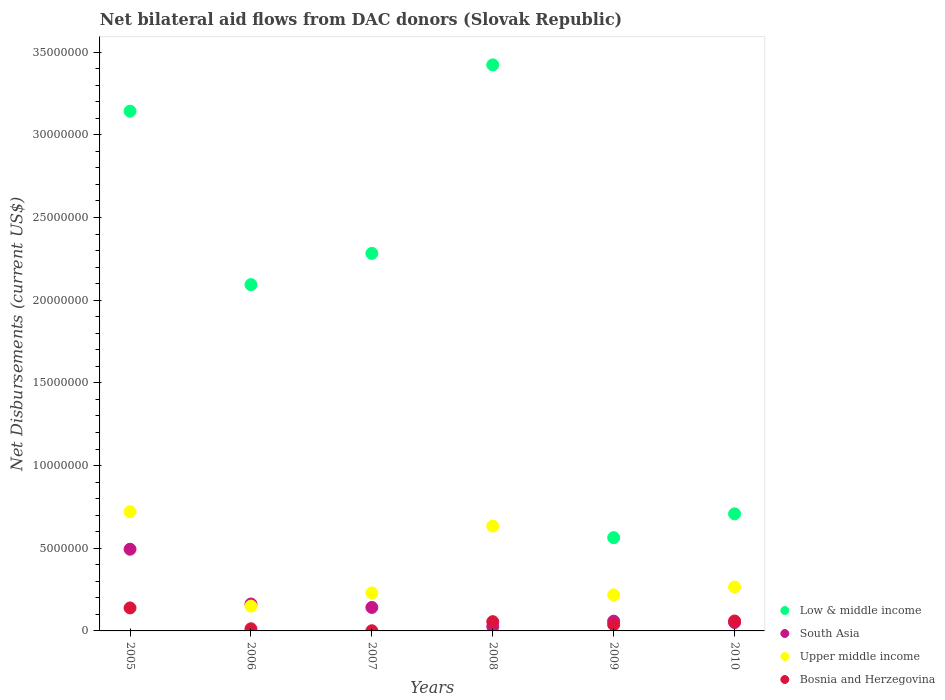Is the number of dotlines equal to the number of legend labels?
Give a very brief answer. Yes. What is the net bilateral aid flows in Upper middle income in 2005?
Ensure brevity in your answer.  7.21e+06. Across all years, what is the maximum net bilateral aid flows in South Asia?
Make the answer very short. 4.94e+06. Across all years, what is the minimum net bilateral aid flows in South Asia?
Offer a terse response. 2.60e+05. In which year was the net bilateral aid flows in Bosnia and Herzegovina maximum?
Provide a succinct answer. 2005. In which year was the net bilateral aid flows in South Asia minimum?
Your answer should be very brief. 2008. What is the total net bilateral aid flows in Low & middle income in the graph?
Make the answer very short. 1.22e+08. What is the difference between the net bilateral aid flows in Upper middle income in 2009 and that in 2010?
Your answer should be very brief. -4.70e+05. What is the difference between the net bilateral aid flows in Bosnia and Herzegovina in 2007 and the net bilateral aid flows in Low & middle income in 2009?
Make the answer very short. -5.63e+06. What is the average net bilateral aid flows in Low & middle income per year?
Ensure brevity in your answer.  2.04e+07. In the year 2007, what is the difference between the net bilateral aid flows in Low & middle income and net bilateral aid flows in Upper middle income?
Make the answer very short. 2.05e+07. What is the ratio of the net bilateral aid flows in Upper middle income in 2007 to that in 2009?
Offer a terse response. 1.06. Is the net bilateral aid flows in Bosnia and Herzegovina in 2008 less than that in 2009?
Offer a very short reply. No. Is the difference between the net bilateral aid flows in Low & middle income in 2005 and 2008 greater than the difference between the net bilateral aid flows in Upper middle income in 2005 and 2008?
Keep it short and to the point. No. What is the difference between the highest and the second highest net bilateral aid flows in Upper middle income?
Offer a very short reply. 8.70e+05. What is the difference between the highest and the lowest net bilateral aid flows in South Asia?
Offer a very short reply. 4.68e+06. In how many years, is the net bilateral aid flows in South Asia greater than the average net bilateral aid flows in South Asia taken over all years?
Give a very brief answer. 2. Is the net bilateral aid flows in Low & middle income strictly greater than the net bilateral aid flows in Bosnia and Herzegovina over the years?
Provide a short and direct response. Yes. Is the net bilateral aid flows in Low & middle income strictly less than the net bilateral aid flows in Bosnia and Herzegovina over the years?
Provide a succinct answer. No. How many years are there in the graph?
Ensure brevity in your answer.  6. Does the graph contain grids?
Provide a short and direct response. No. What is the title of the graph?
Provide a short and direct response. Net bilateral aid flows from DAC donors (Slovak Republic). Does "Cuba" appear as one of the legend labels in the graph?
Offer a very short reply. No. What is the label or title of the Y-axis?
Make the answer very short. Net Disbursements (current US$). What is the Net Disbursements (current US$) of Low & middle income in 2005?
Provide a succinct answer. 3.14e+07. What is the Net Disbursements (current US$) in South Asia in 2005?
Your response must be concise. 4.94e+06. What is the Net Disbursements (current US$) of Upper middle income in 2005?
Ensure brevity in your answer.  7.21e+06. What is the Net Disbursements (current US$) in Bosnia and Herzegovina in 2005?
Your answer should be compact. 1.39e+06. What is the Net Disbursements (current US$) of Low & middle income in 2006?
Provide a short and direct response. 2.09e+07. What is the Net Disbursements (current US$) in South Asia in 2006?
Your answer should be very brief. 1.63e+06. What is the Net Disbursements (current US$) in Upper middle income in 2006?
Give a very brief answer. 1.50e+06. What is the Net Disbursements (current US$) of Low & middle income in 2007?
Provide a short and direct response. 2.28e+07. What is the Net Disbursements (current US$) in South Asia in 2007?
Ensure brevity in your answer.  1.42e+06. What is the Net Disbursements (current US$) of Upper middle income in 2007?
Give a very brief answer. 2.30e+06. What is the Net Disbursements (current US$) in Bosnia and Herzegovina in 2007?
Keep it short and to the point. 10000. What is the Net Disbursements (current US$) in Low & middle income in 2008?
Keep it short and to the point. 3.42e+07. What is the Net Disbursements (current US$) in South Asia in 2008?
Your answer should be very brief. 2.60e+05. What is the Net Disbursements (current US$) in Upper middle income in 2008?
Provide a succinct answer. 6.34e+06. What is the Net Disbursements (current US$) of Bosnia and Herzegovina in 2008?
Your response must be concise. 5.60e+05. What is the Net Disbursements (current US$) in Low & middle income in 2009?
Your answer should be compact. 5.64e+06. What is the Net Disbursements (current US$) in South Asia in 2009?
Keep it short and to the point. 5.90e+05. What is the Net Disbursements (current US$) of Upper middle income in 2009?
Provide a succinct answer. 2.18e+06. What is the Net Disbursements (current US$) in Low & middle income in 2010?
Ensure brevity in your answer.  7.08e+06. What is the Net Disbursements (current US$) of South Asia in 2010?
Keep it short and to the point. 5.10e+05. What is the Net Disbursements (current US$) in Upper middle income in 2010?
Your answer should be very brief. 2.65e+06. What is the Net Disbursements (current US$) in Bosnia and Herzegovina in 2010?
Give a very brief answer. 6.00e+05. Across all years, what is the maximum Net Disbursements (current US$) of Low & middle income?
Your answer should be compact. 3.42e+07. Across all years, what is the maximum Net Disbursements (current US$) in South Asia?
Ensure brevity in your answer.  4.94e+06. Across all years, what is the maximum Net Disbursements (current US$) of Upper middle income?
Offer a very short reply. 7.21e+06. Across all years, what is the maximum Net Disbursements (current US$) of Bosnia and Herzegovina?
Provide a succinct answer. 1.39e+06. Across all years, what is the minimum Net Disbursements (current US$) of Low & middle income?
Your response must be concise. 5.64e+06. Across all years, what is the minimum Net Disbursements (current US$) of South Asia?
Your answer should be very brief. 2.60e+05. Across all years, what is the minimum Net Disbursements (current US$) in Upper middle income?
Make the answer very short. 1.50e+06. What is the total Net Disbursements (current US$) of Low & middle income in the graph?
Make the answer very short. 1.22e+08. What is the total Net Disbursements (current US$) of South Asia in the graph?
Your response must be concise. 9.35e+06. What is the total Net Disbursements (current US$) of Upper middle income in the graph?
Your answer should be very brief. 2.22e+07. What is the total Net Disbursements (current US$) of Bosnia and Herzegovina in the graph?
Your response must be concise. 3.07e+06. What is the difference between the Net Disbursements (current US$) of Low & middle income in 2005 and that in 2006?
Your answer should be very brief. 1.05e+07. What is the difference between the Net Disbursements (current US$) of South Asia in 2005 and that in 2006?
Offer a terse response. 3.31e+06. What is the difference between the Net Disbursements (current US$) in Upper middle income in 2005 and that in 2006?
Offer a very short reply. 5.71e+06. What is the difference between the Net Disbursements (current US$) in Bosnia and Herzegovina in 2005 and that in 2006?
Give a very brief answer. 1.26e+06. What is the difference between the Net Disbursements (current US$) in Low & middle income in 2005 and that in 2007?
Your answer should be compact. 8.60e+06. What is the difference between the Net Disbursements (current US$) in South Asia in 2005 and that in 2007?
Offer a very short reply. 3.52e+06. What is the difference between the Net Disbursements (current US$) of Upper middle income in 2005 and that in 2007?
Ensure brevity in your answer.  4.91e+06. What is the difference between the Net Disbursements (current US$) in Bosnia and Herzegovina in 2005 and that in 2007?
Provide a succinct answer. 1.38e+06. What is the difference between the Net Disbursements (current US$) in Low & middle income in 2005 and that in 2008?
Provide a short and direct response. -2.80e+06. What is the difference between the Net Disbursements (current US$) of South Asia in 2005 and that in 2008?
Ensure brevity in your answer.  4.68e+06. What is the difference between the Net Disbursements (current US$) of Upper middle income in 2005 and that in 2008?
Offer a terse response. 8.70e+05. What is the difference between the Net Disbursements (current US$) in Bosnia and Herzegovina in 2005 and that in 2008?
Your answer should be very brief. 8.30e+05. What is the difference between the Net Disbursements (current US$) in Low & middle income in 2005 and that in 2009?
Your response must be concise. 2.58e+07. What is the difference between the Net Disbursements (current US$) in South Asia in 2005 and that in 2009?
Provide a succinct answer. 4.35e+06. What is the difference between the Net Disbursements (current US$) in Upper middle income in 2005 and that in 2009?
Offer a very short reply. 5.03e+06. What is the difference between the Net Disbursements (current US$) of Bosnia and Herzegovina in 2005 and that in 2009?
Give a very brief answer. 1.01e+06. What is the difference between the Net Disbursements (current US$) in Low & middle income in 2005 and that in 2010?
Provide a succinct answer. 2.44e+07. What is the difference between the Net Disbursements (current US$) of South Asia in 2005 and that in 2010?
Your answer should be compact. 4.43e+06. What is the difference between the Net Disbursements (current US$) in Upper middle income in 2005 and that in 2010?
Ensure brevity in your answer.  4.56e+06. What is the difference between the Net Disbursements (current US$) in Bosnia and Herzegovina in 2005 and that in 2010?
Give a very brief answer. 7.90e+05. What is the difference between the Net Disbursements (current US$) of Low & middle income in 2006 and that in 2007?
Keep it short and to the point. -1.89e+06. What is the difference between the Net Disbursements (current US$) of Upper middle income in 2006 and that in 2007?
Provide a short and direct response. -8.00e+05. What is the difference between the Net Disbursements (current US$) of Bosnia and Herzegovina in 2006 and that in 2007?
Provide a short and direct response. 1.20e+05. What is the difference between the Net Disbursements (current US$) of Low & middle income in 2006 and that in 2008?
Offer a very short reply. -1.33e+07. What is the difference between the Net Disbursements (current US$) in South Asia in 2006 and that in 2008?
Provide a succinct answer. 1.37e+06. What is the difference between the Net Disbursements (current US$) of Upper middle income in 2006 and that in 2008?
Offer a terse response. -4.84e+06. What is the difference between the Net Disbursements (current US$) in Bosnia and Herzegovina in 2006 and that in 2008?
Provide a succinct answer. -4.30e+05. What is the difference between the Net Disbursements (current US$) of Low & middle income in 2006 and that in 2009?
Offer a very short reply. 1.53e+07. What is the difference between the Net Disbursements (current US$) of South Asia in 2006 and that in 2009?
Offer a terse response. 1.04e+06. What is the difference between the Net Disbursements (current US$) in Upper middle income in 2006 and that in 2009?
Offer a terse response. -6.80e+05. What is the difference between the Net Disbursements (current US$) in Bosnia and Herzegovina in 2006 and that in 2009?
Provide a short and direct response. -2.50e+05. What is the difference between the Net Disbursements (current US$) in Low & middle income in 2006 and that in 2010?
Offer a very short reply. 1.39e+07. What is the difference between the Net Disbursements (current US$) in South Asia in 2006 and that in 2010?
Your answer should be compact. 1.12e+06. What is the difference between the Net Disbursements (current US$) of Upper middle income in 2006 and that in 2010?
Ensure brevity in your answer.  -1.15e+06. What is the difference between the Net Disbursements (current US$) in Bosnia and Herzegovina in 2006 and that in 2010?
Give a very brief answer. -4.70e+05. What is the difference between the Net Disbursements (current US$) of Low & middle income in 2007 and that in 2008?
Offer a very short reply. -1.14e+07. What is the difference between the Net Disbursements (current US$) in South Asia in 2007 and that in 2008?
Provide a succinct answer. 1.16e+06. What is the difference between the Net Disbursements (current US$) in Upper middle income in 2007 and that in 2008?
Provide a succinct answer. -4.04e+06. What is the difference between the Net Disbursements (current US$) of Bosnia and Herzegovina in 2007 and that in 2008?
Keep it short and to the point. -5.50e+05. What is the difference between the Net Disbursements (current US$) in Low & middle income in 2007 and that in 2009?
Offer a terse response. 1.72e+07. What is the difference between the Net Disbursements (current US$) of South Asia in 2007 and that in 2009?
Provide a succinct answer. 8.30e+05. What is the difference between the Net Disbursements (current US$) of Upper middle income in 2007 and that in 2009?
Your answer should be very brief. 1.20e+05. What is the difference between the Net Disbursements (current US$) of Bosnia and Herzegovina in 2007 and that in 2009?
Provide a short and direct response. -3.70e+05. What is the difference between the Net Disbursements (current US$) in Low & middle income in 2007 and that in 2010?
Make the answer very short. 1.58e+07. What is the difference between the Net Disbursements (current US$) in South Asia in 2007 and that in 2010?
Offer a terse response. 9.10e+05. What is the difference between the Net Disbursements (current US$) in Upper middle income in 2007 and that in 2010?
Your response must be concise. -3.50e+05. What is the difference between the Net Disbursements (current US$) of Bosnia and Herzegovina in 2007 and that in 2010?
Offer a terse response. -5.90e+05. What is the difference between the Net Disbursements (current US$) in Low & middle income in 2008 and that in 2009?
Your response must be concise. 2.86e+07. What is the difference between the Net Disbursements (current US$) of South Asia in 2008 and that in 2009?
Offer a terse response. -3.30e+05. What is the difference between the Net Disbursements (current US$) of Upper middle income in 2008 and that in 2009?
Offer a terse response. 4.16e+06. What is the difference between the Net Disbursements (current US$) of Bosnia and Herzegovina in 2008 and that in 2009?
Your answer should be compact. 1.80e+05. What is the difference between the Net Disbursements (current US$) in Low & middle income in 2008 and that in 2010?
Ensure brevity in your answer.  2.72e+07. What is the difference between the Net Disbursements (current US$) of South Asia in 2008 and that in 2010?
Make the answer very short. -2.50e+05. What is the difference between the Net Disbursements (current US$) of Upper middle income in 2008 and that in 2010?
Your response must be concise. 3.69e+06. What is the difference between the Net Disbursements (current US$) in Bosnia and Herzegovina in 2008 and that in 2010?
Your response must be concise. -4.00e+04. What is the difference between the Net Disbursements (current US$) in Low & middle income in 2009 and that in 2010?
Ensure brevity in your answer.  -1.44e+06. What is the difference between the Net Disbursements (current US$) of Upper middle income in 2009 and that in 2010?
Ensure brevity in your answer.  -4.70e+05. What is the difference between the Net Disbursements (current US$) of Bosnia and Herzegovina in 2009 and that in 2010?
Give a very brief answer. -2.20e+05. What is the difference between the Net Disbursements (current US$) in Low & middle income in 2005 and the Net Disbursements (current US$) in South Asia in 2006?
Your answer should be compact. 2.98e+07. What is the difference between the Net Disbursements (current US$) in Low & middle income in 2005 and the Net Disbursements (current US$) in Upper middle income in 2006?
Your response must be concise. 2.99e+07. What is the difference between the Net Disbursements (current US$) in Low & middle income in 2005 and the Net Disbursements (current US$) in Bosnia and Herzegovina in 2006?
Provide a short and direct response. 3.13e+07. What is the difference between the Net Disbursements (current US$) in South Asia in 2005 and the Net Disbursements (current US$) in Upper middle income in 2006?
Make the answer very short. 3.44e+06. What is the difference between the Net Disbursements (current US$) of South Asia in 2005 and the Net Disbursements (current US$) of Bosnia and Herzegovina in 2006?
Keep it short and to the point. 4.81e+06. What is the difference between the Net Disbursements (current US$) of Upper middle income in 2005 and the Net Disbursements (current US$) of Bosnia and Herzegovina in 2006?
Offer a terse response. 7.08e+06. What is the difference between the Net Disbursements (current US$) in Low & middle income in 2005 and the Net Disbursements (current US$) in South Asia in 2007?
Your answer should be very brief. 3.00e+07. What is the difference between the Net Disbursements (current US$) in Low & middle income in 2005 and the Net Disbursements (current US$) in Upper middle income in 2007?
Provide a succinct answer. 2.91e+07. What is the difference between the Net Disbursements (current US$) of Low & middle income in 2005 and the Net Disbursements (current US$) of Bosnia and Herzegovina in 2007?
Make the answer very short. 3.14e+07. What is the difference between the Net Disbursements (current US$) in South Asia in 2005 and the Net Disbursements (current US$) in Upper middle income in 2007?
Offer a very short reply. 2.64e+06. What is the difference between the Net Disbursements (current US$) of South Asia in 2005 and the Net Disbursements (current US$) of Bosnia and Herzegovina in 2007?
Offer a terse response. 4.93e+06. What is the difference between the Net Disbursements (current US$) of Upper middle income in 2005 and the Net Disbursements (current US$) of Bosnia and Herzegovina in 2007?
Give a very brief answer. 7.20e+06. What is the difference between the Net Disbursements (current US$) of Low & middle income in 2005 and the Net Disbursements (current US$) of South Asia in 2008?
Ensure brevity in your answer.  3.12e+07. What is the difference between the Net Disbursements (current US$) in Low & middle income in 2005 and the Net Disbursements (current US$) in Upper middle income in 2008?
Offer a very short reply. 2.51e+07. What is the difference between the Net Disbursements (current US$) in Low & middle income in 2005 and the Net Disbursements (current US$) in Bosnia and Herzegovina in 2008?
Make the answer very short. 3.09e+07. What is the difference between the Net Disbursements (current US$) of South Asia in 2005 and the Net Disbursements (current US$) of Upper middle income in 2008?
Offer a very short reply. -1.40e+06. What is the difference between the Net Disbursements (current US$) of South Asia in 2005 and the Net Disbursements (current US$) of Bosnia and Herzegovina in 2008?
Your response must be concise. 4.38e+06. What is the difference between the Net Disbursements (current US$) in Upper middle income in 2005 and the Net Disbursements (current US$) in Bosnia and Herzegovina in 2008?
Provide a short and direct response. 6.65e+06. What is the difference between the Net Disbursements (current US$) in Low & middle income in 2005 and the Net Disbursements (current US$) in South Asia in 2009?
Offer a terse response. 3.08e+07. What is the difference between the Net Disbursements (current US$) of Low & middle income in 2005 and the Net Disbursements (current US$) of Upper middle income in 2009?
Provide a short and direct response. 2.92e+07. What is the difference between the Net Disbursements (current US$) of Low & middle income in 2005 and the Net Disbursements (current US$) of Bosnia and Herzegovina in 2009?
Your answer should be compact. 3.10e+07. What is the difference between the Net Disbursements (current US$) in South Asia in 2005 and the Net Disbursements (current US$) in Upper middle income in 2009?
Ensure brevity in your answer.  2.76e+06. What is the difference between the Net Disbursements (current US$) of South Asia in 2005 and the Net Disbursements (current US$) of Bosnia and Herzegovina in 2009?
Offer a very short reply. 4.56e+06. What is the difference between the Net Disbursements (current US$) of Upper middle income in 2005 and the Net Disbursements (current US$) of Bosnia and Herzegovina in 2009?
Make the answer very short. 6.83e+06. What is the difference between the Net Disbursements (current US$) of Low & middle income in 2005 and the Net Disbursements (current US$) of South Asia in 2010?
Your response must be concise. 3.09e+07. What is the difference between the Net Disbursements (current US$) of Low & middle income in 2005 and the Net Disbursements (current US$) of Upper middle income in 2010?
Your answer should be very brief. 2.88e+07. What is the difference between the Net Disbursements (current US$) of Low & middle income in 2005 and the Net Disbursements (current US$) of Bosnia and Herzegovina in 2010?
Your response must be concise. 3.08e+07. What is the difference between the Net Disbursements (current US$) of South Asia in 2005 and the Net Disbursements (current US$) of Upper middle income in 2010?
Offer a very short reply. 2.29e+06. What is the difference between the Net Disbursements (current US$) of South Asia in 2005 and the Net Disbursements (current US$) of Bosnia and Herzegovina in 2010?
Your response must be concise. 4.34e+06. What is the difference between the Net Disbursements (current US$) of Upper middle income in 2005 and the Net Disbursements (current US$) of Bosnia and Herzegovina in 2010?
Ensure brevity in your answer.  6.61e+06. What is the difference between the Net Disbursements (current US$) in Low & middle income in 2006 and the Net Disbursements (current US$) in South Asia in 2007?
Your response must be concise. 1.95e+07. What is the difference between the Net Disbursements (current US$) in Low & middle income in 2006 and the Net Disbursements (current US$) in Upper middle income in 2007?
Your answer should be compact. 1.86e+07. What is the difference between the Net Disbursements (current US$) of Low & middle income in 2006 and the Net Disbursements (current US$) of Bosnia and Herzegovina in 2007?
Keep it short and to the point. 2.09e+07. What is the difference between the Net Disbursements (current US$) of South Asia in 2006 and the Net Disbursements (current US$) of Upper middle income in 2007?
Ensure brevity in your answer.  -6.70e+05. What is the difference between the Net Disbursements (current US$) of South Asia in 2006 and the Net Disbursements (current US$) of Bosnia and Herzegovina in 2007?
Offer a very short reply. 1.62e+06. What is the difference between the Net Disbursements (current US$) in Upper middle income in 2006 and the Net Disbursements (current US$) in Bosnia and Herzegovina in 2007?
Your answer should be compact. 1.49e+06. What is the difference between the Net Disbursements (current US$) of Low & middle income in 2006 and the Net Disbursements (current US$) of South Asia in 2008?
Offer a very short reply. 2.07e+07. What is the difference between the Net Disbursements (current US$) in Low & middle income in 2006 and the Net Disbursements (current US$) in Upper middle income in 2008?
Give a very brief answer. 1.46e+07. What is the difference between the Net Disbursements (current US$) of Low & middle income in 2006 and the Net Disbursements (current US$) of Bosnia and Herzegovina in 2008?
Provide a short and direct response. 2.04e+07. What is the difference between the Net Disbursements (current US$) of South Asia in 2006 and the Net Disbursements (current US$) of Upper middle income in 2008?
Keep it short and to the point. -4.71e+06. What is the difference between the Net Disbursements (current US$) of South Asia in 2006 and the Net Disbursements (current US$) of Bosnia and Herzegovina in 2008?
Provide a succinct answer. 1.07e+06. What is the difference between the Net Disbursements (current US$) of Upper middle income in 2006 and the Net Disbursements (current US$) of Bosnia and Herzegovina in 2008?
Offer a very short reply. 9.40e+05. What is the difference between the Net Disbursements (current US$) of Low & middle income in 2006 and the Net Disbursements (current US$) of South Asia in 2009?
Provide a succinct answer. 2.04e+07. What is the difference between the Net Disbursements (current US$) in Low & middle income in 2006 and the Net Disbursements (current US$) in Upper middle income in 2009?
Your answer should be compact. 1.88e+07. What is the difference between the Net Disbursements (current US$) in Low & middle income in 2006 and the Net Disbursements (current US$) in Bosnia and Herzegovina in 2009?
Give a very brief answer. 2.06e+07. What is the difference between the Net Disbursements (current US$) in South Asia in 2006 and the Net Disbursements (current US$) in Upper middle income in 2009?
Your answer should be compact. -5.50e+05. What is the difference between the Net Disbursements (current US$) of South Asia in 2006 and the Net Disbursements (current US$) of Bosnia and Herzegovina in 2009?
Offer a very short reply. 1.25e+06. What is the difference between the Net Disbursements (current US$) of Upper middle income in 2006 and the Net Disbursements (current US$) of Bosnia and Herzegovina in 2009?
Make the answer very short. 1.12e+06. What is the difference between the Net Disbursements (current US$) of Low & middle income in 2006 and the Net Disbursements (current US$) of South Asia in 2010?
Make the answer very short. 2.04e+07. What is the difference between the Net Disbursements (current US$) in Low & middle income in 2006 and the Net Disbursements (current US$) in Upper middle income in 2010?
Ensure brevity in your answer.  1.83e+07. What is the difference between the Net Disbursements (current US$) of Low & middle income in 2006 and the Net Disbursements (current US$) of Bosnia and Herzegovina in 2010?
Offer a very short reply. 2.03e+07. What is the difference between the Net Disbursements (current US$) of South Asia in 2006 and the Net Disbursements (current US$) of Upper middle income in 2010?
Provide a succinct answer. -1.02e+06. What is the difference between the Net Disbursements (current US$) in South Asia in 2006 and the Net Disbursements (current US$) in Bosnia and Herzegovina in 2010?
Your answer should be compact. 1.03e+06. What is the difference between the Net Disbursements (current US$) in Low & middle income in 2007 and the Net Disbursements (current US$) in South Asia in 2008?
Ensure brevity in your answer.  2.26e+07. What is the difference between the Net Disbursements (current US$) in Low & middle income in 2007 and the Net Disbursements (current US$) in Upper middle income in 2008?
Keep it short and to the point. 1.65e+07. What is the difference between the Net Disbursements (current US$) in Low & middle income in 2007 and the Net Disbursements (current US$) in Bosnia and Herzegovina in 2008?
Provide a succinct answer. 2.23e+07. What is the difference between the Net Disbursements (current US$) in South Asia in 2007 and the Net Disbursements (current US$) in Upper middle income in 2008?
Your answer should be very brief. -4.92e+06. What is the difference between the Net Disbursements (current US$) in South Asia in 2007 and the Net Disbursements (current US$) in Bosnia and Herzegovina in 2008?
Offer a terse response. 8.60e+05. What is the difference between the Net Disbursements (current US$) in Upper middle income in 2007 and the Net Disbursements (current US$) in Bosnia and Herzegovina in 2008?
Give a very brief answer. 1.74e+06. What is the difference between the Net Disbursements (current US$) in Low & middle income in 2007 and the Net Disbursements (current US$) in South Asia in 2009?
Offer a terse response. 2.22e+07. What is the difference between the Net Disbursements (current US$) in Low & middle income in 2007 and the Net Disbursements (current US$) in Upper middle income in 2009?
Your answer should be very brief. 2.06e+07. What is the difference between the Net Disbursements (current US$) of Low & middle income in 2007 and the Net Disbursements (current US$) of Bosnia and Herzegovina in 2009?
Ensure brevity in your answer.  2.24e+07. What is the difference between the Net Disbursements (current US$) in South Asia in 2007 and the Net Disbursements (current US$) in Upper middle income in 2009?
Provide a succinct answer. -7.60e+05. What is the difference between the Net Disbursements (current US$) in South Asia in 2007 and the Net Disbursements (current US$) in Bosnia and Herzegovina in 2009?
Your answer should be compact. 1.04e+06. What is the difference between the Net Disbursements (current US$) in Upper middle income in 2007 and the Net Disbursements (current US$) in Bosnia and Herzegovina in 2009?
Make the answer very short. 1.92e+06. What is the difference between the Net Disbursements (current US$) of Low & middle income in 2007 and the Net Disbursements (current US$) of South Asia in 2010?
Your answer should be very brief. 2.23e+07. What is the difference between the Net Disbursements (current US$) of Low & middle income in 2007 and the Net Disbursements (current US$) of Upper middle income in 2010?
Make the answer very short. 2.02e+07. What is the difference between the Net Disbursements (current US$) of Low & middle income in 2007 and the Net Disbursements (current US$) of Bosnia and Herzegovina in 2010?
Your response must be concise. 2.22e+07. What is the difference between the Net Disbursements (current US$) in South Asia in 2007 and the Net Disbursements (current US$) in Upper middle income in 2010?
Your answer should be compact. -1.23e+06. What is the difference between the Net Disbursements (current US$) in South Asia in 2007 and the Net Disbursements (current US$) in Bosnia and Herzegovina in 2010?
Ensure brevity in your answer.  8.20e+05. What is the difference between the Net Disbursements (current US$) in Upper middle income in 2007 and the Net Disbursements (current US$) in Bosnia and Herzegovina in 2010?
Give a very brief answer. 1.70e+06. What is the difference between the Net Disbursements (current US$) in Low & middle income in 2008 and the Net Disbursements (current US$) in South Asia in 2009?
Ensure brevity in your answer.  3.36e+07. What is the difference between the Net Disbursements (current US$) of Low & middle income in 2008 and the Net Disbursements (current US$) of Upper middle income in 2009?
Offer a very short reply. 3.20e+07. What is the difference between the Net Disbursements (current US$) of Low & middle income in 2008 and the Net Disbursements (current US$) of Bosnia and Herzegovina in 2009?
Provide a short and direct response. 3.38e+07. What is the difference between the Net Disbursements (current US$) in South Asia in 2008 and the Net Disbursements (current US$) in Upper middle income in 2009?
Offer a very short reply. -1.92e+06. What is the difference between the Net Disbursements (current US$) in Upper middle income in 2008 and the Net Disbursements (current US$) in Bosnia and Herzegovina in 2009?
Your answer should be compact. 5.96e+06. What is the difference between the Net Disbursements (current US$) of Low & middle income in 2008 and the Net Disbursements (current US$) of South Asia in 2010?
Offer a very short reply. 3.37e+07. What is the difference between the Net Disbursements (current US$) in Low & middle income in 2008 and the Net Disbursements (current US$) in Upper middle income in 2010?
Your answer should be very brief. 3.16e+07. What is the difference between the Net Disbursements (current US$) in Low & middle income in 2008 and the Net Disbursements (current US$) in Bosnia and Herzegovina in 2010?
Keep it short and to the point. 3.36e+07. What is the difference between the Net Disbursements (current US$) in South Asia in 2008 and the Net Disbursements (current US$) in Upper middle income in 2010?
Keep it short and to the point. -2.39e+06. What is the difference between the Net Disbursements (current US$) in Upper middle income in 2008 and the Net Disbursements (current US$) in Bosnia and Herzegovina in 2010?
Your response must be concise. 5.74e+06. What is the difference between the Net Disbursements (current US$) of Low & middle income in 2009 and the Net Disbursements (current US$) of South Asia in 2010?
Your response must be concise. 5.13e+06. What is the difference between the Net Disbursements (current US$) of Low & middle income in 2009 and the Net Disbursements (current US$) of Upper middle income in 2010?
Provide a succinct answer. 2.99e+06. What is the difference between the Net Disbursements (current US$) of Low & middle income in 2009 and the Net Disbursements (current US$) of Bosnia and Herzegovina in 2010?
Provide a short and direct response. 5.04e+06. What is the difference between the Net Disbursements (current US$) in South Asia in 2009 and the Net Disbursements (current US$) in Upper middle income in 2010?
Offer a terse response. -2.06e+06. What is the difference between the Net Disbursements (current US$) in Upper middle income in 2009 and the Net Disbursements (current US$) in Bosnia and Herzegovina in 2010?
Give a very brief answer. 1.58e+06. What is the average Net Disbursements (current US$) in Low & middle income per year?
Your answer should be very brief. 2.04e+07. What is the average Net Disbursements (current US$) of South Asia per year?
Give a very brief answer. 1.56e+06. What is the average Net Disbursements (current US$) of Upper middle income per year?
Provide a short and direct response. 3.70e+06. What is the average Net Disbursements (current US$) in Bosnia and Herzegovina per year?
Your answer should be very brief. 5.12e+05. In the year 2005, what is the difference between the Net Disbursements (current US$) in Low & middle income and Net Disbursements (current US$) in South Asia?
Make the answer very short. 2.65e+07. In the year 2005, what is the difference between the Net Disbursements (current US$) of Low & middle income and Net Disbursements (current US$) of Upper middle income?
Offer a terse response. 2.42e+07. In the year 2005, what is the difference between the Net Disbursements (current US$) of Low & middle income and Net Disbursements (current US$) of Bosnia and Herzegovina?
Give a very brief answer. 3.00e+07. In the year 2005, what is the difference between the Net Disbursements (current US$) of South Asia and Net Disbursements (current US$) of Upper middle income?
Make the answer very short. -2.27e+06. In the year 2005, what is the difference between the Net Disbursements (current US$) of South Asia and Net Disbursements (current US$) of Bosnia and Herzegovina?
Your answer should be compact. 3.55e+06. In the year 2005, what is the difference between the Net Disbursements (current US$) of Upper middle income and Net Disbursements (current US$) of Bosnia and Herzegovina?
Provide a succinct answer. 5.82e+06. In the year 2006, what is the difference between the Net Disbursements (current US$) in Low & middle income and Net Disbursements (current US$) in South Asia?
Give a very brief answer. 1.93e+07. In the year 2006, what is the difference between the Net Disbursements (current US$) in Low & middle income and Net Disbursements (current US$) in Upper middle income?
Ensure brevity in your answer.  1.94e+07. In the year 2006, what is the difference between the Net Disbursements (current US$) of Low & middle income and Net Disbursements (current US$) of Bosnia and Herzegovina?
Offer a very short reply. 2.08e+07. In the year 2006, what is the difference between the Net Disbursements (current US$) in South Asia and Net Disbursements (current US$) in Upper middle income?
Provide a short and direct response. 1.30e+05. In the year 2006, what is the difference between the Net Disbursements (current US$) in South Asia and Net Disbursements (current US$) in Bosnia and Herzegovina?
Provide a short and direct response. 1.50e+06. In the year 2006, what is the difference between the Net Disbursements (current US$) of Upper middle income and Net Disbursements (current US$) of Bosnia and Herzegovina?
Give a very brief answer. 1.37e+06. In the year 2007, what is the difference between the Net Disbursements (current US$) of Low & middle income and Net Disbursements (current US$) of South Asia?
Give a very brief answer. 2.14e+07. In the year 2007, what is the difference between the Net Disbursements (current US$) in Low & middle income and Net Disbursements (current US$) in Upper middle income?
Provide a short and direct response. 2.05e+07. In the year 2007, what is the difference between the Net Disbursements (current US$) in Low & middle income and Net Disbursements (current US$) in Bosnia and Herzegovina?
Give a very brief answer. 2.28e+07. In the year 2007, what is the difference between the Net Disbursements (current US$) in South Asia and Net Disbursements (current US$) in Upper middle income?
Make the answer very short. -8.80e+05. In the year 2007, what is the difference between the Net Disbursements (current US$) in South Asia and Net Disbursements (current US$) in Bosnia and Herzegovina?
Provide a succinct answer. 1.41e+06. In the year 2007, what is the difference between the Net Disbursements (current US$) in Upper middle income and Net Disbursements (current US$) in Bosnia and Herzegovina?
Offer a very short reply. 2.29e+06. In the year 2008, what is the difference between the Net Disbursements (current US$) in Low & middle income and Net Disbursements (current US$) in South Asia?
Your answer should be compact. 3.40e+07. In the year 2008, what is the difference between the Net Disbursements (current US$) in Low & middle income and Net Disbursements (current US$) in Upper middle income?
Offer a very short reply. 2.79e+07. In the year 2008, what is the difference between the Net Disbursements (current US$) of Low & middle income and Net Disbursements (current US$) of Bosnia and Herzegovina?
Provide a succinct answer. 3.37e+07. In the year 2008, what is the difference between the Net Disbursements (current US$) in South Asia and Net Disbursements (current US$) in Upper middle income?
Offer a very short reply. -6.08e+06. In the year 2008, what is the difference between the Net Disbursements (current US$) of Upper middle income and Net Disbursements (current US$) of Bosnia and Herzegovina?
Give a very brief answer. 5.78e+06. In the year 2009, what is the difference between the Net Disbursements (current US$) of Low & middle income and Net Disbursements (current US$) of South Asia?
Ensure brevity in your answer.  5.05e+06. In the year 2009, what is the difference between the Net Disbursements (current US$) in Low & middle income and Net Disbursements (current US$) in Upper middle income?
Give a very brief answer. 3.46e+06. In the year 2009, what is the difference between the Net Disbursements (current US$) of Low & middle income and Net Disbursements (current US$) of Bosnia and Herzegovina?
Your answer should be very brief. 5.26e+06. In the year 2009, what is the difference between the Net Disbursements (current US$) of South Asia and Net Disbursements (current US$) of Upper middle income?
Offer a terse response. -1.59e+06. In the year 2009, what is the difference between the Net Disbursements (current US$) in South Asia and Net Disbursements (current US$) in Bosnia and Herzegovina?
Your answer should be very brief. 2.10e+05. In the year 2009, what is the difference between the Net Disbursements (current US$) in Upper middle income and Net Disbursements (current US$) in Bosnia and Herzegovina?
Give a very brief answer. 1.80e+06. In the year 2010, what is the difference between the Net Disbursements (current US$) of Low & middle income and Net Disbursements (current US$) of South Asia?
Your response must be concise. 6.57e+06. In the year 2010, what is the difference between the Net Disbursements (current US$) in Low & middle income and Net Disbursements (current US$) in Upper middle income?
Ensure brevity in your answer.  4.43e+06. In the year 2010, what is the difference between the Net Disbursements (current US$) in Low & middle income and Net Disbursements (current US$) in Bosnia and Herzegovina?
Provide a succinct answer. 6.48e+06. In the year 2010, what is the difference between the Net Disbursements (current US$) in South Asia and Net Disbursements (current US$) in Upper middle income?
Keep it short and to the point. -2.14e+06. In the year 2010, what is the difference between the Net Disbursements (current US$) of Upper middle income and Net Disbursements (current US$) of Bosnia and Herzegovina?
Your response must be concise. 2.05e+06. What is the ratio of the Net Disbursements (current US$) in Low & middle income in 2005 to that in 2006?
Ensure brevity in your answer.  1.5. What is the ratio of the Net Disbursements (current US$) of South Asia in 2005 to that in 2006?
Provide a short and direct response. 3.03. What is the ratio of the Net Disbursements (current US$) of Upper middle income in 2005 to that in 2006?
Give a very brief answer. 4.81. What is the ratio of the Net Disbursements (current US$) of Bosnia and Herzegovina in 2005 to that in 2006?
Keep it short and to the point. 10.69. What is the ratio of the Net Disbursements (current US$) of Low & middle income in 2005 to that in 2007?
Offer a terse response. 1.38. What is the ratio of the Net Disbursements (current US$) of South Asia in 2005 to that in 2007?
Your answer should be very brief. 3.48. What is the ratio of the Net Disbursements (current US$) in Upper middle income in 2005 to that in 2007?
Give a very brief answer. 3.13. What is the ratio of the Net Disbursements (current US$) of Bosnia and Herzegovina in 2005 to that in 2007?
Give a very brief answer. 139. What is the ratio of the Net Disbursements (current US$) of Low & middle income in 2005 to that in 2008?
Keep it short and to the point. 0.92. What is the ratio of the Net Disbursements (current US$) in South Asia in 2005 to that in 2008?
Give a very brief answer. 19. What is the ratio of the Net Disbursements (current US$) in Upper middle income in 2005 to that in 2008?
Your response must be concise. 1.14. What is the ratio of the Net Disbursements (current US$) in Bosnia and Herzegovina in 2005 to that in 2008?
Your answer should be compact. 2.48. What is the ratio of the Net Disbursements (current US$) of Low & middle income in 2005 to that in 2009?
Your response must be concise. 5.57. What is the ratio of the Net Disbursements (current US$) in South Asia in 2005 to that in 2009?
Your answer should be very brief. 8.37. What is the ratio of the Net Disbursements (current US$) of Upper middle income in 2005 to that in 2009?
Keep it short and to the point. 3.31. What is the ratio of the Net Disbursements (current US$) in Bosnia and Herzegovina in 2005 to that in 2009?
Give a very brief answer. 3.66. What is the ratio of the Net Disbursements (current US$) in Low & middle income in 2005 to that in 2010?
Your answer should be compact. 4.44. What is the ratio of the Net Disbursements (current US$) of South Asia in 2005 to that in 2010?
Your response must be concise. 9.69. What is the ratio of the Net Disbursements (current US$) in Upper middle income in 2005 to that in 2010?
Your response must be concise. 2.72. What is the ratio of the Net Disbursements (current US$) of Bosnia and Herzegovina in 2005 to that in 2010?
Offer a terse response. 2.32. What is the ratio of the Net Disbursements (current US$) in Low & middle income in 2006 to that in 2007?
Your response must be concise. 0.92. What is the ratio of the Net Disbursements (current US$) of South Asia in 2006 to that in 2007?
Give a very brief answer. 1.15. What is the ratio of the Net Disbursements (current US$) in Upper middle income in 2006 to that in 2007?
Offer a very short reply. 0.65. What is the ratio of the Net Disbursements (current US$) in Bosnia and Herzegovina in 2006 to that in 2007?
Provide a succinct answer. 13. What is the ratio of the Net Disbursements (current US$) of Low & middle income in 2006 to that in 2008?
Your answer should be compact. 0.61. What is the ratio of the Net Disbursements (current US$) of South Asia in 2006 to that in 2008?
Provide a short and direct response. 6.27. What is the ratio of the Net Disbursements (current US$) of Upper middle income in 2006 to that in 2008?
Your answer should be very brief. 0.24. What is the ratio of the Net Disbursements (current US$) of Bosnia and Herzegovina in 2006 to that in 2008?
Your response must be concise. 0.23. What is the ratio of the Net Disbursements (current US$) of Low & middle income in 2006 to that in 2009?
Offer a very short reply. 3.71. What is the ratio of the Net Disbursements (current US$) of South Asia in 2006 to that in 2009?
Keep it short and to the point. 2.76. What is the ratio of the Net Disbursements (current US$) of Upper middle income in 2006 to that in 2009?
Make the answer very short. 0.69. What is the ratio of the Net Disbursements (current US$) in Bosnia and Herzegovina in 2006 to that in 2009?
Provide a succinct answer. 0.34. What is the ratio of the Net Disbursements (current US$) of Low & middle income in 2006 to that in 2010?
Ensure brevity in your answer.  2.96. What is the ratio of the Net Disbursements (current US$) of South Asia in 2006 to that in 2010?
Your answer should be very brief. 3.2. What is the ratio of the Net Disbursements (current US$) in Upper middle income in 2006 to that in 2010?
Ensure brevity in your answer.  0.57. What is the ratio of the Net Disbursements (current US$) in Bosnia and Herzegovina in 2006 to that in 2010?
Give a very brief answer. 0.22. What is the ratio of the Net Disbursements (current US$) in Low & middle income in 2007 to that in 2008?
Ensure brevity in your answer.  0.67. What is the ratio of the Net Disbursements (current US$) in South Asia in 2007 to that in 2008?
Offer a terse response. 5.46. What is the ratio of the Net Disbursements (current US$) of Upper middle income in 2007 to that in 2008?
Ensure brevity in your answer.  0.36. What is the ratio of the Net Disbursements (current US$) of Bosnia and Herzegovina in 2007 to that in 2008?
Make the answer very short. 0.02. What is the ratio of the Net Disbursements (current US$) in Low & middle income in 2007 to that in 2009?
Provide a short and direct response. 4.05. What is the ratio of the Net Disbursements (current US$) of South Asia in 2007 to that in 2009?
Offer a terse response. 2.41. What is the ratio of the Net Disbursements (current US$) of Upper middle income in 2007 to that in 2009?
Provide a short and direct response. 1.05. What is the ratio of the Net Disbursements (current US$) in Bosnia and Herzegovina in 2007 to that in 2009?
Make the answer very short. 0.03. What is the ratio of the Net Disbursements (current US$) of Low & middle income in 2007 to that in 2010?
Give a very brief answer. 3.22. What is the ratio of the Net Disbursements (current US$) of South Asia in 2007 to that in 2010?
Offer a terse response. 2.78. What is the ratio of the Net Disbursements (current US$) in Upper middle income in 2007 to that in 2010?
Ensure brevity in your answer.  0.87. What is the ratio of the Net Disbursements (current US$) of Bosnia and Herzegovina in 2007 to that in 2010?
Offer a terse response. 0.02. What is the ratio of the Net Disbursements (current US$) in Low & middle income in 2008 to that in 2009?
Make the answer very short. 6.07. What is the ratio of the Net Disbursements (current US$) of South Asia in 2008 to that in 2009?
Offer a terse response. 0.44. What is the ratio of the Net Disbursements (current US$) in Upper middle income in 2008 to that in 2009?
Ensure brevity in your answer.  2.91. What is the ratio of the Net Disbursements (current US$) in Bosnia and Herzegovina in 2008 to that in 2009?
Provide a succinct answer. 1.47. What is the ratio of the Net Disbursements (current US$) of Low & middle income in 2008 to that in 2010?
Ensure brevity in your answer.  4.83. What is the ratio of the Net Disbursements (current US$) of South Asia in 2008 to that in 2010?
Your answer should be compact. 0.51. What is the ratio of the Net Disbursements (current US$) in Upper middle income in 2008 to that in 2010?
Provide a succinct answer. 2.39. What is the ratio of the Net Disbursements (current US$) of Bosnia and Herzegovina in 2008 to that in 2010?
Offer a very short reply. 0.93. What is the ratio of the Net Disbursements (current US$) in Low & middle income in 2009 to that in 2010?
Offer a terse response. 0.8. What is the ratio of the Net Disbursements (current US$) of South Asia in 2009 to that in 2010?
Make the answer very short. 1.16. What is the ratio of the Net Disbursements (current US$) of Upper middle income in 2009 to that in 2010?
Your response must be concise. 0.82. What is the ratio of the Net Disbursements (current US$) in Bosnia and Herzegovina in 2009 to that in 2010?
Offer a terse response. 0.63. What is the difference between the highest and the second highest Net Disbursements (current US$) in Low & middle income?
Make the answer very short. 2.80e+06. What is the difference between the highest and the second highest Net Disbursements (current US$) of South Asia?
Your answer should be very brief. 3.31e+06. What is the difference between the highest and the second highest Net Disbursements (current US$) in Upper middle income?
Your response must be concise. 8.70e+05. What is the difference between the highest and the second highest Net Disbursements (current US$) of Bosnia and Herzegovina?
Offer a terse response. 7.90e+05. What is the difference between the highest and the lowest Net Disbursements (current US$) in Low & middle income?
Your answer should be very brief. 2.86e+07. What is the difference between the highest and the lowest Net Disbursements (current US$) in South Asia?
Keep it short and to the point. 4.68e+06. What is the difference between the highest and the lowest Net Disbursements (current US$) of Upper middle income?
Your response must be concise. 5.71e+06. What is the difference between the highest and the lowest Net Disbursements (current US$) of Bosnia and Herzegovina?
Offer a terse response. 1.38e+06. 